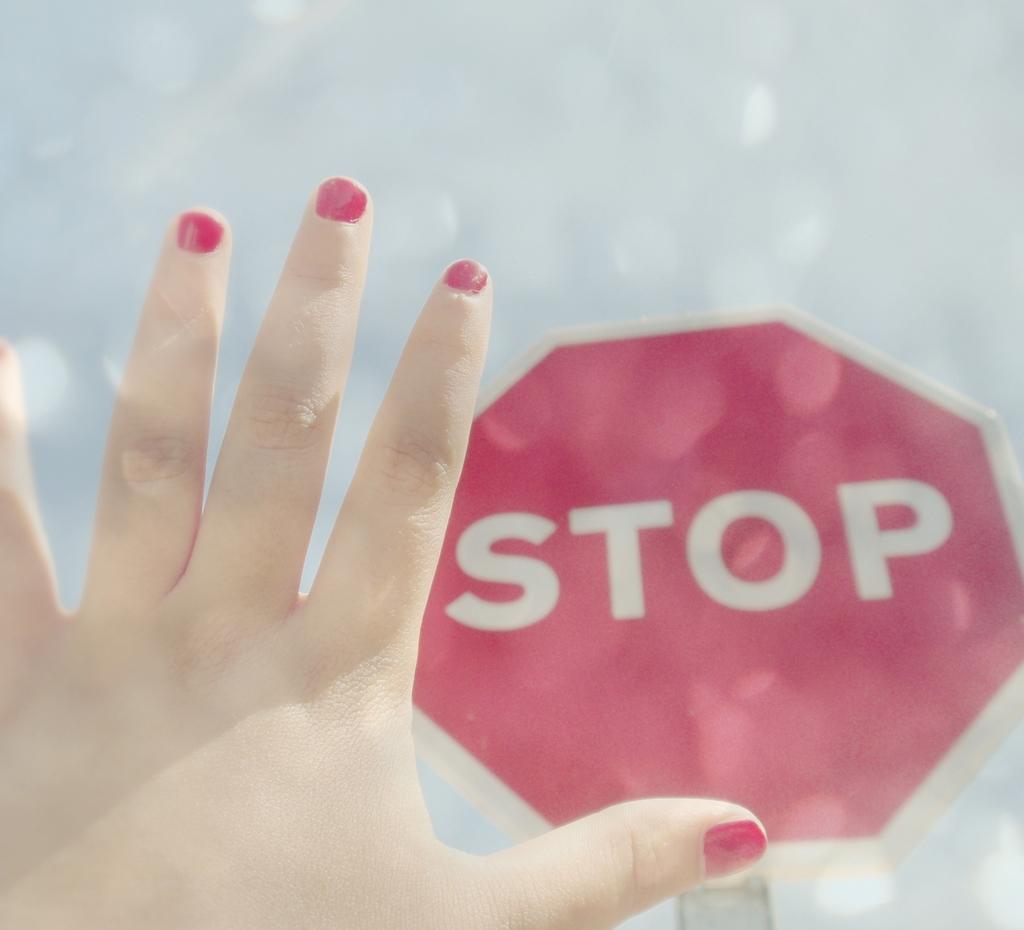Please provide a concise description of this image. In this image we can see a person's hand and a sign board. 